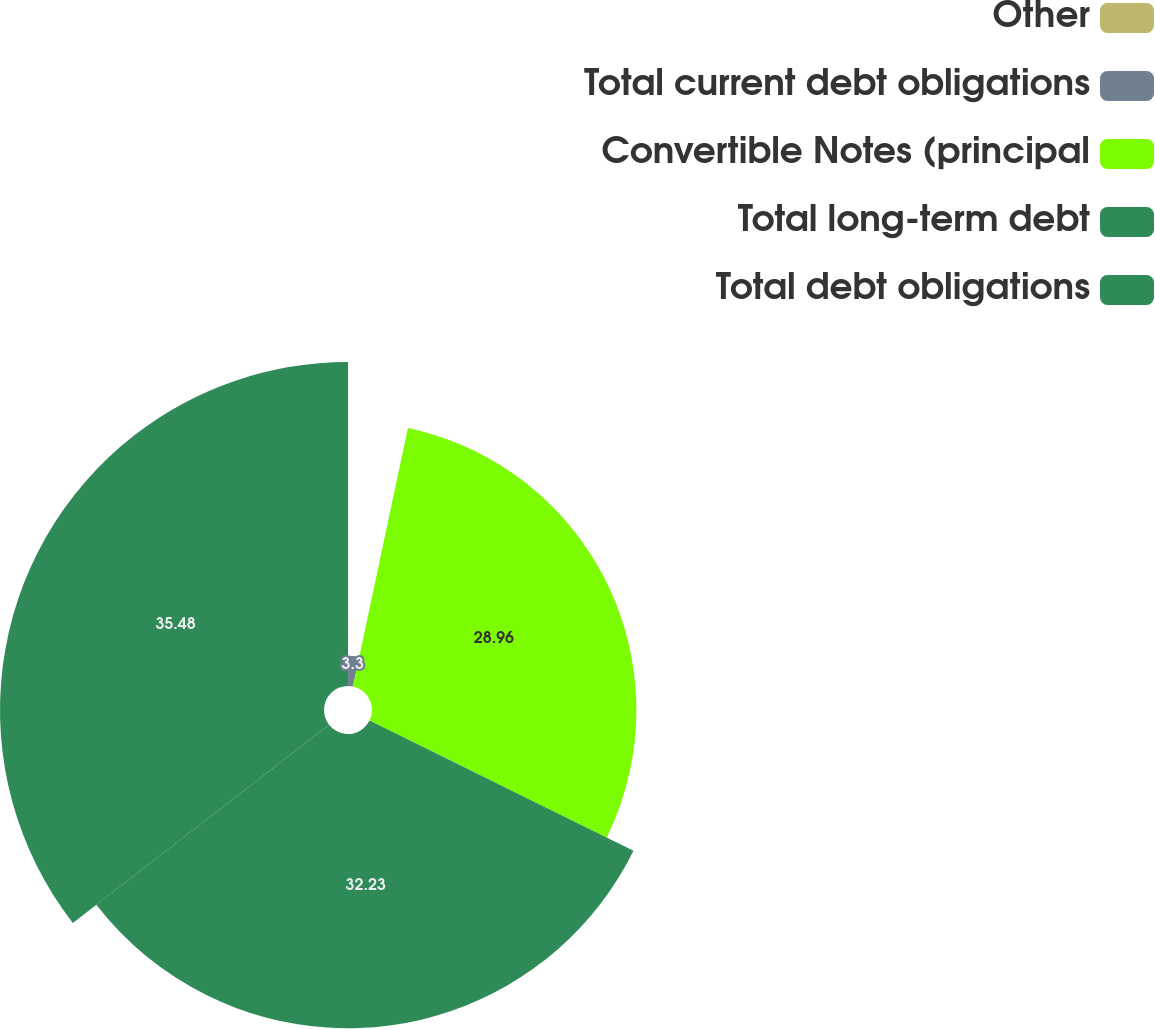Convert chart to OTSL. <chart><loc_0><loc_0><loc_500><loc_500><pie_chart><fcel>Other<fcel>Total current debt obligations<fcel>Convertible Notes (principal<fcel>Total long-term debt<fcel>Total debt obligations<nl><fcel>0.03%<fcel>3.3%<fcel>28.96%<fcel>32.23%<fcel>35.49%<nl></chart> 